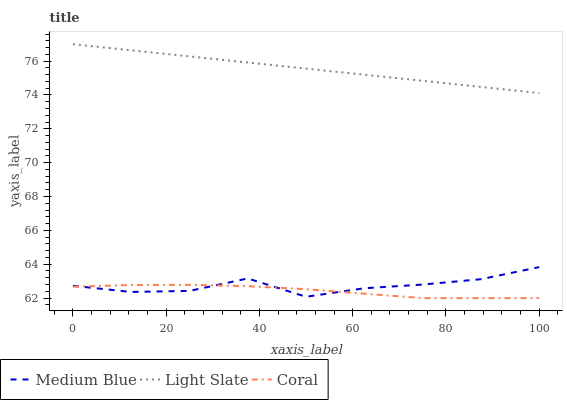Does Coral have the minimum area under the curve?
Answer yes or no. Yes. Does Light Slate have the maximum area under the curve?
Answer yes or no. Yes. Does Medium Blue have the minimum area under the curve?
Answer yes or no. No. Does Medium Blue have the maximum area under the curve?
Answer yes or no. No. Is Light Slate the smoothest?
Answer yes or no. Yes. Is Medium Blue the roughest?
Answer yes or no. Yes. Is Coral the smoothest?
Answer yes or no. No. Is Coral the roughest?
Answer yes or no. No. Does Coral have the lowest value?
Answer yes or no. Yes. Does Medium Blue have the lowest value?
Answer yes or no. No. Does Light Slate have the highest value?
Answer yes or no. Yes. Does Medium Blue have the highest value?
Answer yes or no. No. Is Medium Blue less than Light Slate?
Answer yes or no. Yes. Is Light Slate greater than Coral?
Answer yes or no. Yes. Does Coral intersect Medium Blue?
Answer yes or no. Yes. Is Coral less than Medium Blue?
Answer yes or no. No. Is Coral greater than Medium Blue?
Answer yes or no. No. Does Medium Blue intersect Light Slate?
Answer yes or no. No. 